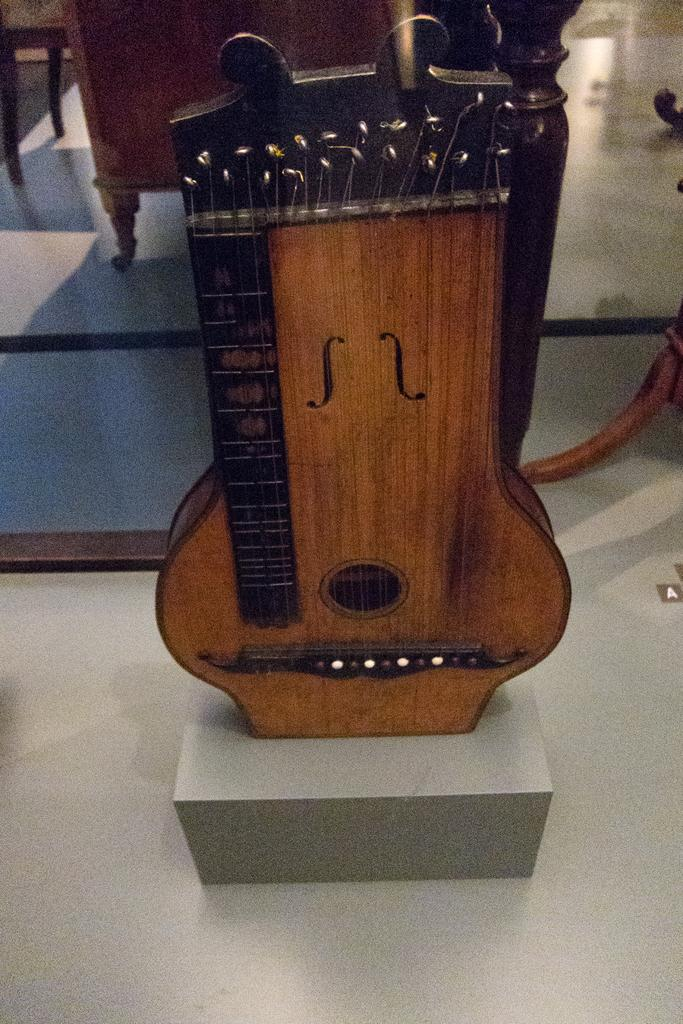What type of musical instrument can be seen in the image? There is a musical instrument made of wood in the image. Where is the musical instrument located? The musical instrument is placed on the floor. What can be seen in the background of the image? There are chairs visible in the background of the image. What type of plate is being used to design the musical instrument in the image? There is no plate present in the image, and the musical instrument is not being designed; it is already made. 